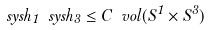Convert formula to latex. <formula><loc_0><loc_0><loc_500><loc_500>\ s y s h _ { 1 } \ s y s h _ { 3 } \leq C \ v o l ( S ^ { 1 } \times S ^ { 3 } )</formula> 